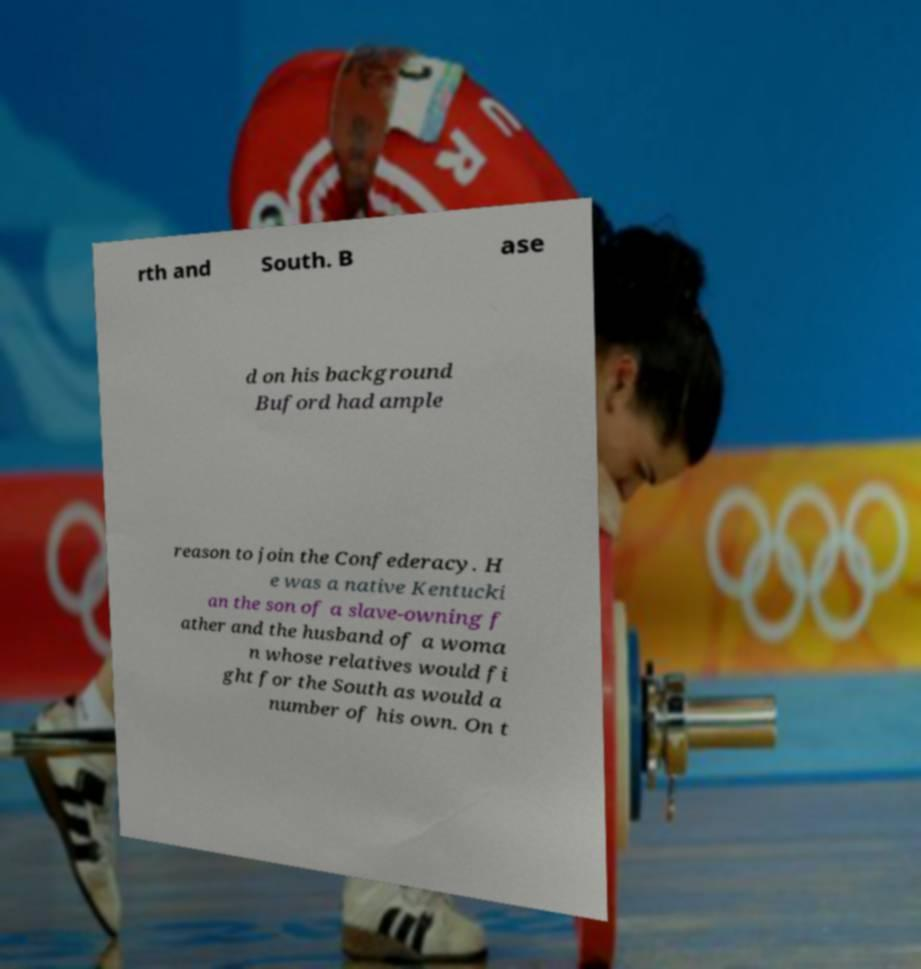What messages or text are displayed in this image? I need them in a readable, typed format. rth and South. B ase d on his background Buford had ample reason to join the Confederacy. H e was a native Kentucki an the son of a slave-owning f ather and the husband of a woma n whose relatives would fi ght for the South as would a number of his own. On t 